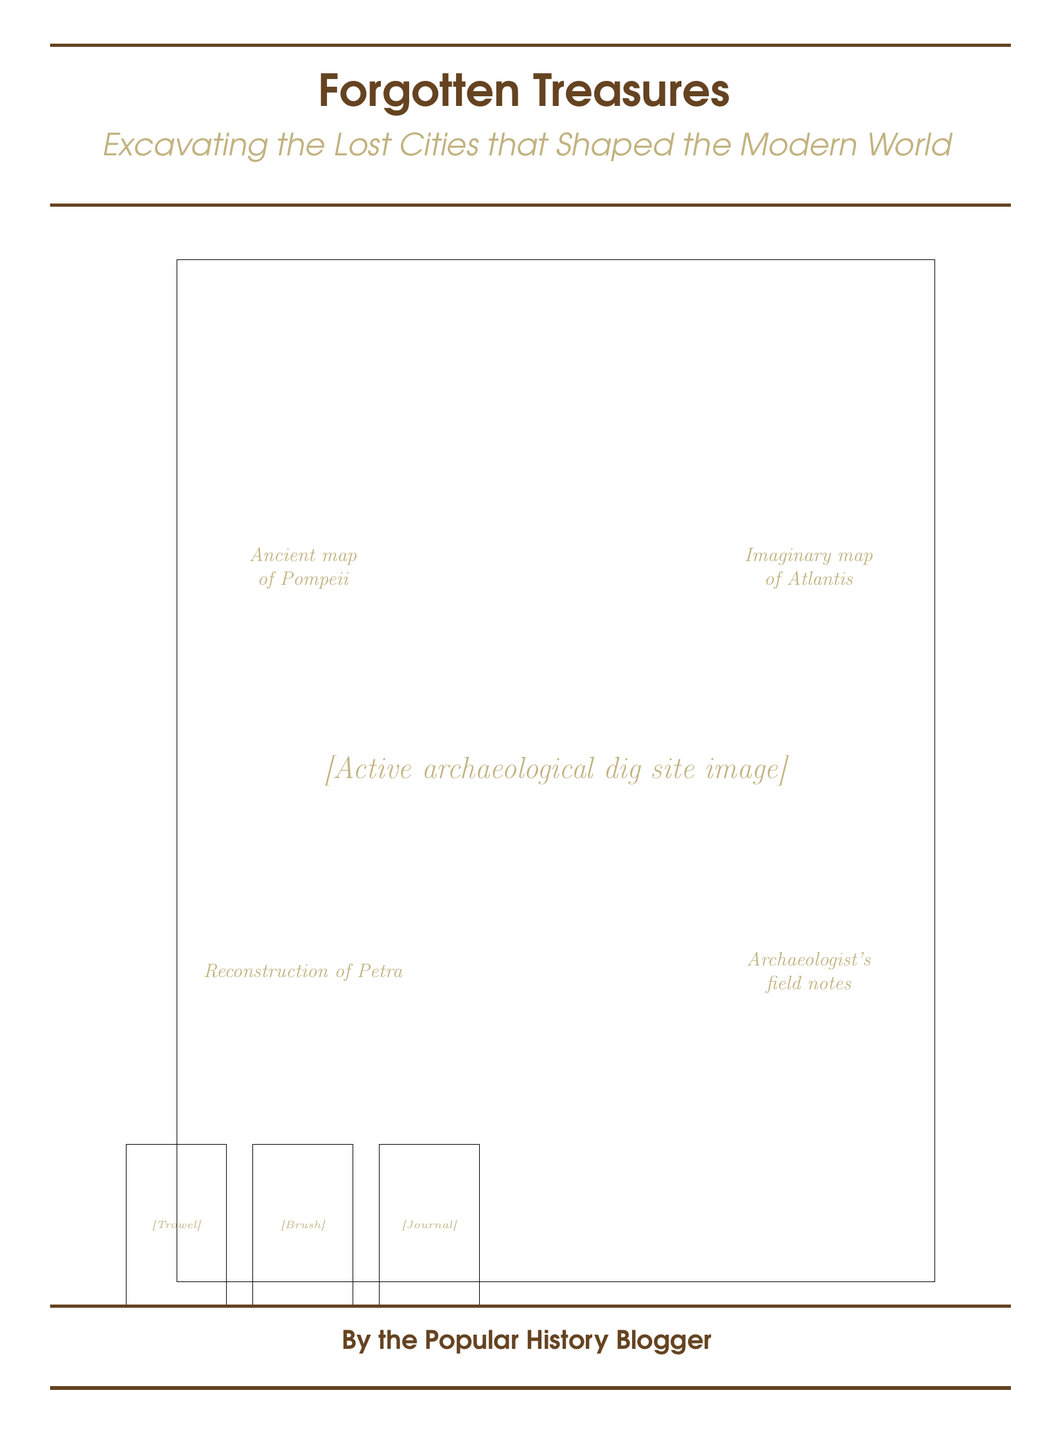What is the title of the book? The title is prominently displayed at the top of the cover in a large font.
Answer: Forgotten Treasures What is the subtitle of the book? The subtitle provides additional context about the book's content and is italicized below the title.
Answer: Excavating the Lost Cities that Shaped the Modern World What image is featured on the cover? The cover prominently includes an image that depicts an archaeological dig site.
Answer: Active archaeological dig site image Which lost city is represented by an ancient map on the cover? One of the overlays on the cover features an ancient map related to a well-known lost city, Pompeii.
Answer: Pompeii What rediscovered city is reconstructed in the cover imagery? The cover includes a visual representation of a historical city that was rediscovered during archaeological digs.
Answer: Petra How many vintage excavation tools are shown on the cover? The cover displays three vintage tools arranged at the bottom.
Answer: Three Who is the author of the book? The author's name is stated at the bottom of the cover in a bold font.
Answer: The Popular History Blogger What design element frames the book title and subtitle? The title and subtitle are framed by horizontal lines of a particular color.
Answer: Brown lines What type of notes is included in the cover design? The design features a visual element representing a specific type of document used in the field.
Answer: Archaeologist's field notes 